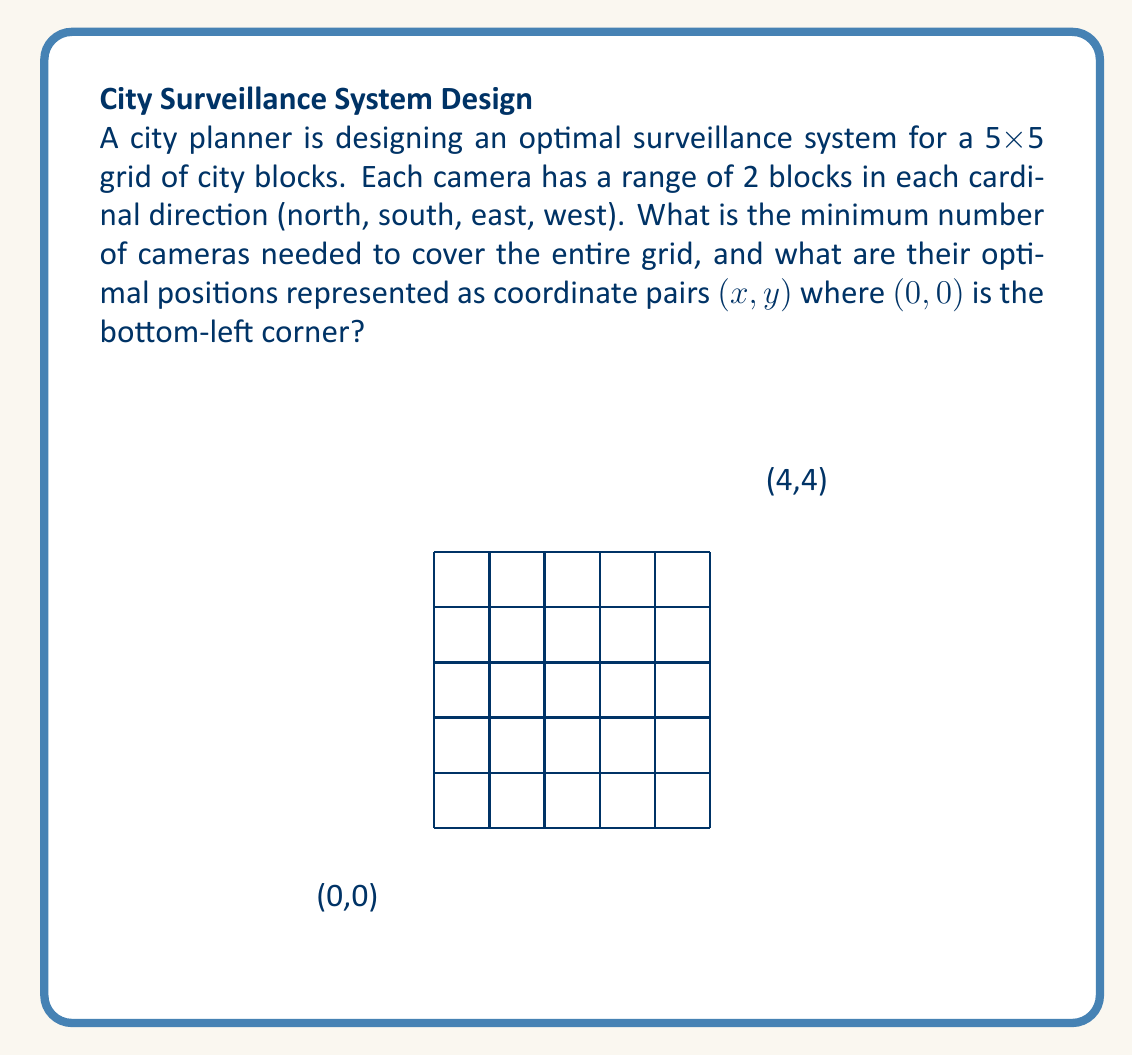Could you help me with this problem? Let's approach this step-by-step:

1) First, we need to understand the coverage of each camera. A camera can cover a 5x5 area centered on itself.

2) To minimize the number of cameras, we should place them in a way that their coverage areas overlap as little as possible while still covering the entire grid.

3) Given the 5x5 grid, we can cover it with four cameras placed at the following coordinates:

   $$(1,1), (1,3), (3,1), (3,3)$$

4) Let's verify the coverage:
   - Camera at (1,1) covers (0,0) to (3,3)
   - Camera at (1,3) covers (0,1) to (3,5)
   - Camera at (3,1) covers (1,0) to (5,3)
   - Camera at (3,3) covers (1,1) to (5,5)

5) This arrangement ensures that every block in the 5x5 grid is covered by at least one camera.

6) We can prove this is the minimum number by contradiction:
   - If we use only 3 cameras, there will always be at least one uncovered corner in a 5x5 grid, regardless of camera placement.

Therefore, the minimum number of cameras needed is 4, placed at the coordinates listed above.
Answer: 4 cameras at (1,1), (1,3), (3,1), (3,3) 